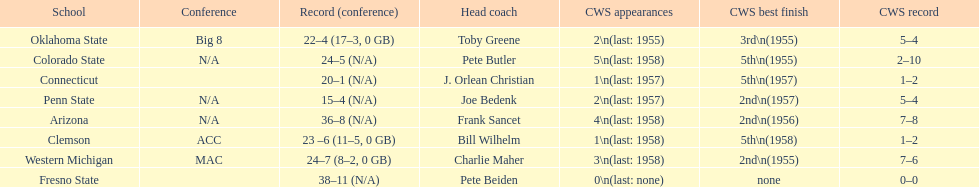Which school has no cws appearances? Fresno State. 